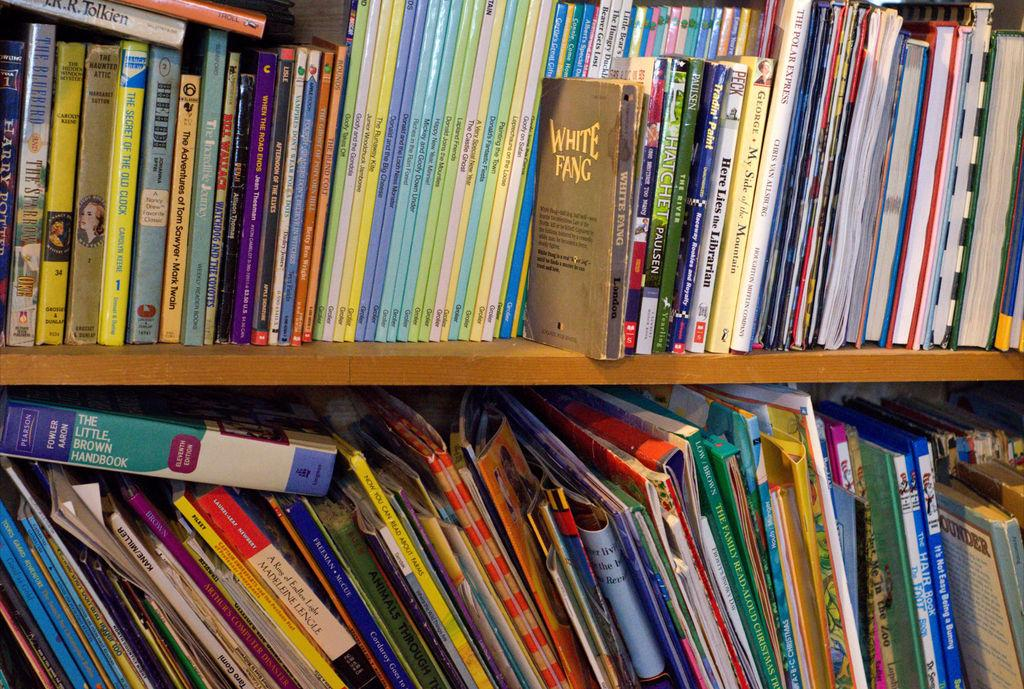<image>
Write a terse but informative summary of the picture. White Fang book, Hatchet, and here lies the Librarian books on the shelf. 